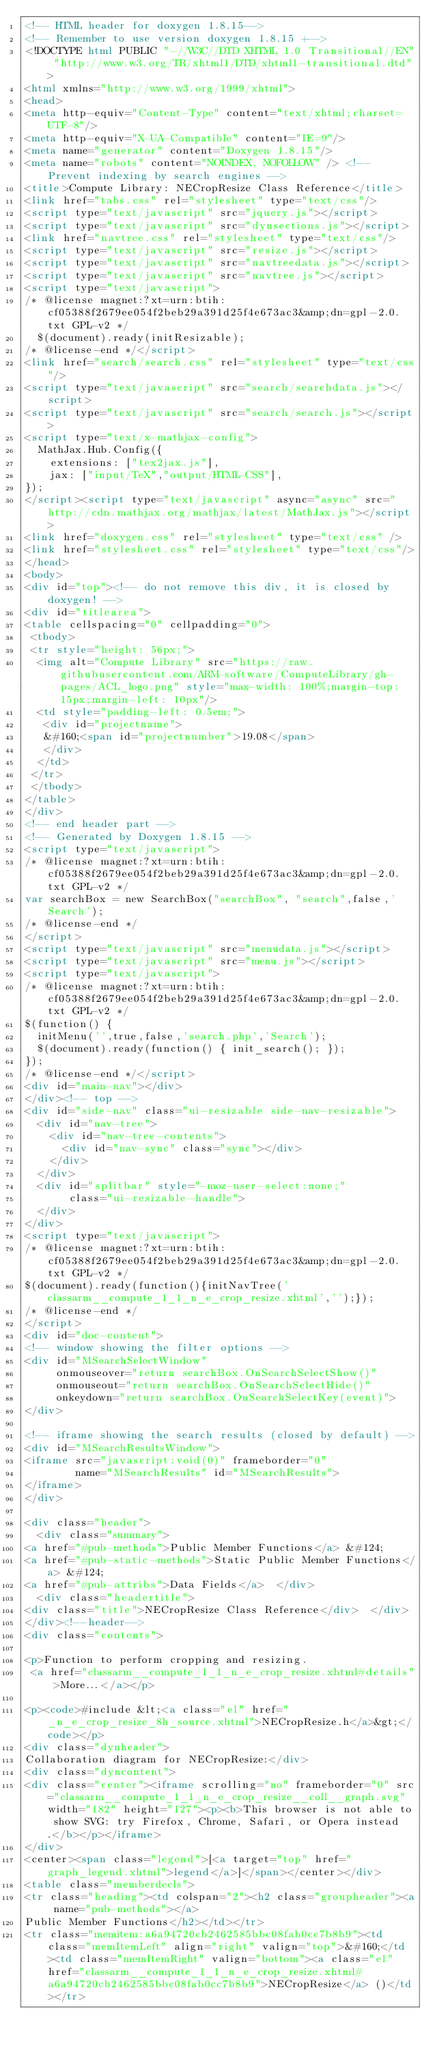<code> <loc_0><loc_0><loc_500><loc_500><_HTML_><!-- HTML header for doxygen 1.8.15-->
<!-- Remember to use version doxygen 1.8.15 +-->
<!DOCTYPE html PUBLIC "-//W3C//DTD XHTML 1.0 Transitional//EN" "http://www.w3.org/TR/xhtml1/DTD/xhtml1-transitional.dtd">
<html xmlns="http://www.w3.org/1999/xhtml">
<head>
<meta http-equiv="Content-Type" content="text/xhtml;charset=UTF-8"/>
<meta http-equiv="X-UA-Compatible" content="IE=9"/>
<meta name="generator" content="Doxygen 1.8.15"/>
<meta name="robots" content="NOINDEX, NOFOLLOW" /> <!-- Prevent indexing by search engines -->
<title>Compute Library: NECropResize Class Reference</title>
<link href="tabs.css" rel="stylesheet" type="text/css"/>
<script type="text/javascript" src="jquery.js"></script>
<script type="text/javascript" src="dynsections.js"></script>
<link href="navtree.css" rel="stylesheet" type="text/css"/>
<script type="text/javascript" src="resize.js"></script>
<script type="text/javascript" src="navtreedata.js"></script>
<script type="text/javascript" src="navtree.js"></script>
<script type="text/javascript">
/* @license magnet:?xt=urn:btih:cf05388f2679ee054f2beb29a391d25f4e673ac3&amp;dn=gpl-2.0.txt GPL-v2 */
  $(document).ready(initResizable);
/* @license-end */</script>
<link href="search/search.css" rel="stylesheet" type="text/css"/>
<script type="text/javascript" src="search/searchdata.js"></script>
<script type="text/javascript" src="search/search.js"></script>
<script type="text/x-mathjax-config">
  MathJax.Hub.Config({
    extensions: ["tex2jax.js"],
    jax: ["input/TeX","output/HTML-CSS"],
});
</script><script type="text/javascript" async="async" src="http://cdn.mathjax.org/mathjax/latest/MathJax.js"></script>
<link href="doxygen.css" rel="stylesheet" type="text/css" />
<link href="stylesheet.css" rel="stylesheet" type="text/css"/>
</head>
<body>
<div id="top"><!-- do not remove this div, it is closed by doxygen! -->
<div id="titlearea">
<table cellspacing="0" cellpadding="0">
 <tbody>
 <tr style="height: 56px;">
  <img alt="Compute Library" src="https://raw.githubusercontent.com/ARM-software/ComputeLibrary/gh-pages/ACL_logo.png" style="max-width: 100%;margin-top: 15px;margin-left: 10px"/>
  <td style="padding-left: 0.5em;">
   <div id="projectname">
   &#160;<span id="projectnumber">19.08</span>
   </div>
  </td>
 </tr>
 </tbody>
</table>
</div>
<!-- end header part -->
<!-- Generated by Doxygen 1.8.15 -->
<script type="text/javascript">
/* @license magnet:?xt=urn:btih:cf05388f2679ee054f2beb29a391d25f4e673ac3&amp;dn=gpl-2.0.txt GPL-v2 */
var searchBox = new SearchBox("searchBox", "search",false,'Search');
/* @license-end */
</script>
<script type="text/javascript" src="menudata.js"></script>
<script type="text/javascript" src="menu.js"></script>
<script type="text/javascript">
/* @license magnet:?xt=urn:btih:cf05388f2679ee054f2beb29a391d25f4e673ac3&amp;dn=gpl-2.0.txt GPL-v2 */
$(function() {
  initMenu('',true,false,'search.php','Search');
  $(document).ready(function() { init_search(); });
});
/* @license-end */</script>
<div id="main-nav"></div>
</div><!-- top -->
<div id="side-nav" class="ui-resizable side-nav-resizable">
  <div id="nav-tree">
    <div id="nav-tree-contents">
      <div id="nav-sync" class="sync"></div>
    </div>
  </div>
  <div id="splitbar" style="-moz-user-select:none;" 
       class="ui-resizable-handle">
  </div>
</div>
<script type="text/javascript">
/* @license magnet:?xt=urn:btih:cf05388f2679ee054f2beb29a391d25f4e673ac3&amp;dn=gpl-2.0.txt GPL-v2 */
$(document).ready(function(){initNavTree('classarm__compute_1_1_n_e_crop_resize.xhtml','');});
/* @license-end */
</script>
<div id="doc-content">
<!-- window showing the filter options -->
<div id="MSearchSelectWindow"
     onmouseover="return searchBox.OnSearchSelectShow()"
     onmouseout="return searchBox.OnSearchSelectHide()"
     onkeydown="return searchBox.OnSearchSelectKey(event)">
</div>

<!-- iframe showing the search results (closed by default) -->
<div id="MSearchResultsWindow">
<iframe src="javascript:void(0)" frameborder="0" 
        name="MSearchResults" id="MSearchResults">
</iframe>
</div>

<div class="header">
  <div class="summary">
<a href="#pub-methods">Public Member Functions</a> &#124;
<a href="#pub-static-methods">Static Public Member Functions</a> &#124;
<a href="#pub-attribs">Data Fields</a>  </div>
  <div class="headertitle">
<div class="title">NECropResize Class Reference</div>  </div>
</div><!--header-->
<div class="contents">

<p>Function to perform cropping and resizing.  
 <a href="classarm__compute_1_1_n_e_crop_resize.xhtml#details">More...</a></p>

<p><code>#include &lt;<a class="el" href="_n_e_crop_resize_8h_source.xhtml">NECropResize.h</a>&gt;</code></p>
<div class="dynheader">
Collaboration diagram for NECropResize:</div>
<div class="dyncontent">
<div class="center"><iframe scrolling="no" frameborder="0" src="classarm__compute_1_1_n_e_crop_resize__coll__graph.svg" width="182" height="127"><p><b>This browser is not able to show SVG: try Firefox, Chrome, Safari, or Opera instead.</b></p></iframe>
</div>
<center><span class="legend">[<a target="top" href="graph_legend.xhtml">legend</a>]</span></center></div>
<table class="memberdecls">
<tr class="heading"><td colspan="2"><h2 class="groupheader"><a name="pub-methods"></a>
Public Member Functions</h2></td></tr>
<tr class="memitem:a6a94720cb2462585bbc08fab0cc7b8b9"><td class="memItemLeft" align="right" valign="top">&#160;</td><td class="memItemRight" valign="bottom"><a class="el" href="classarm__compute_1_1_n_e_crop_resize.xhtml#a6a94720cb2462585bbc08fab0cc7b8b9">NECropResize</a> ()</td></tr></code> 